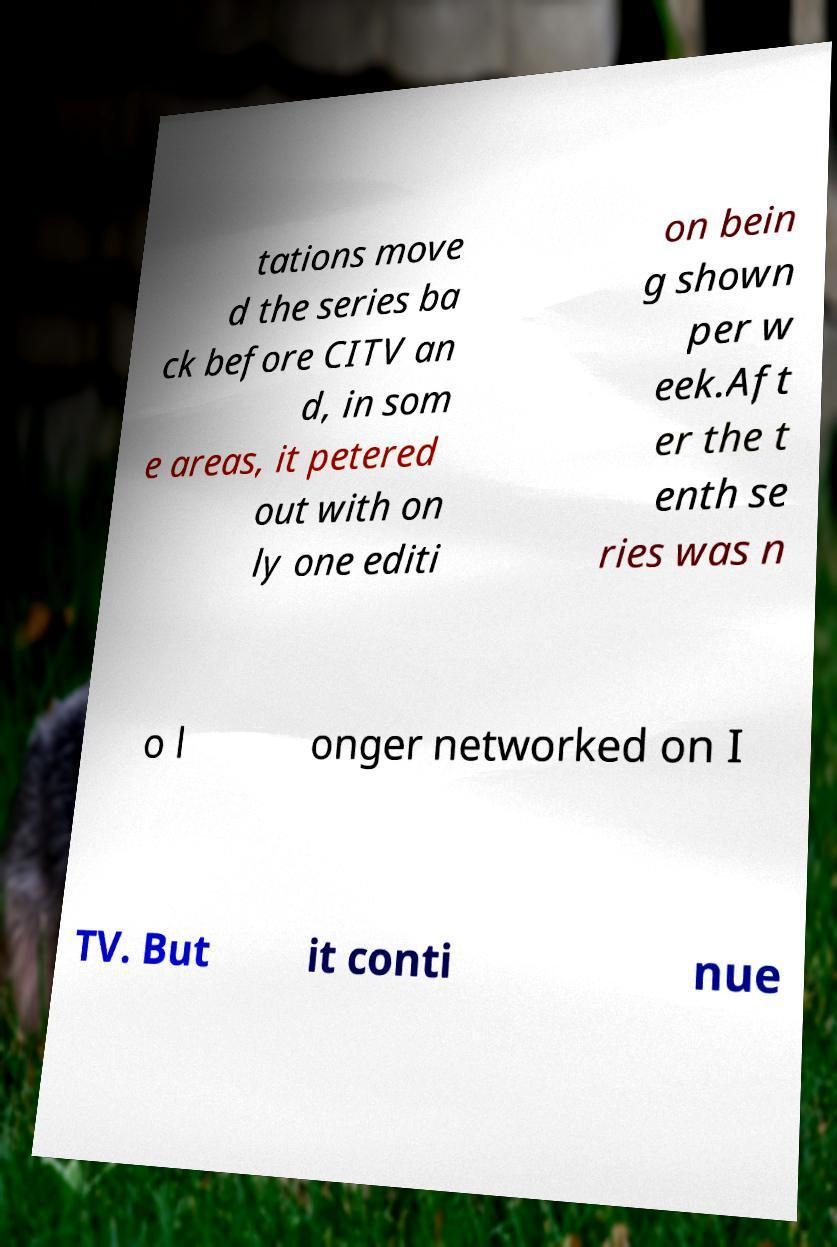Could you extract and type out the text from this image? tations move d the series ba ck before CITV an d, in som e areas, it petered out with on ly one editi on bein g shown per w eek.Aft er the t enth se ries was n o l onger networked on I TV. But it conti nue 